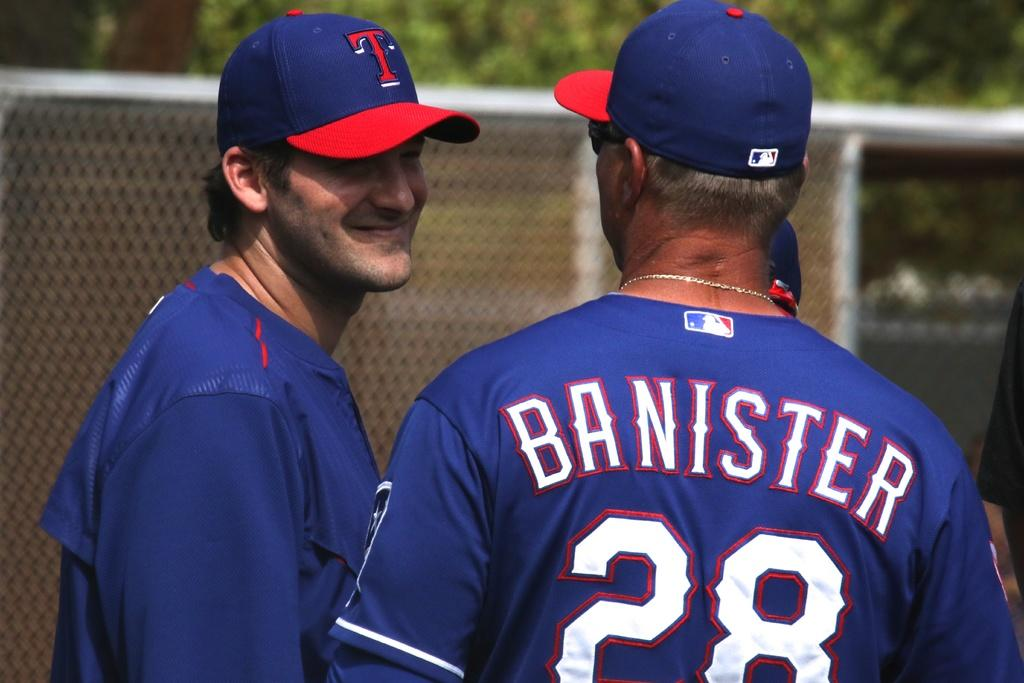<image>
Summarize the visual content of the image. A baseball player named Banister is talking to another player. 